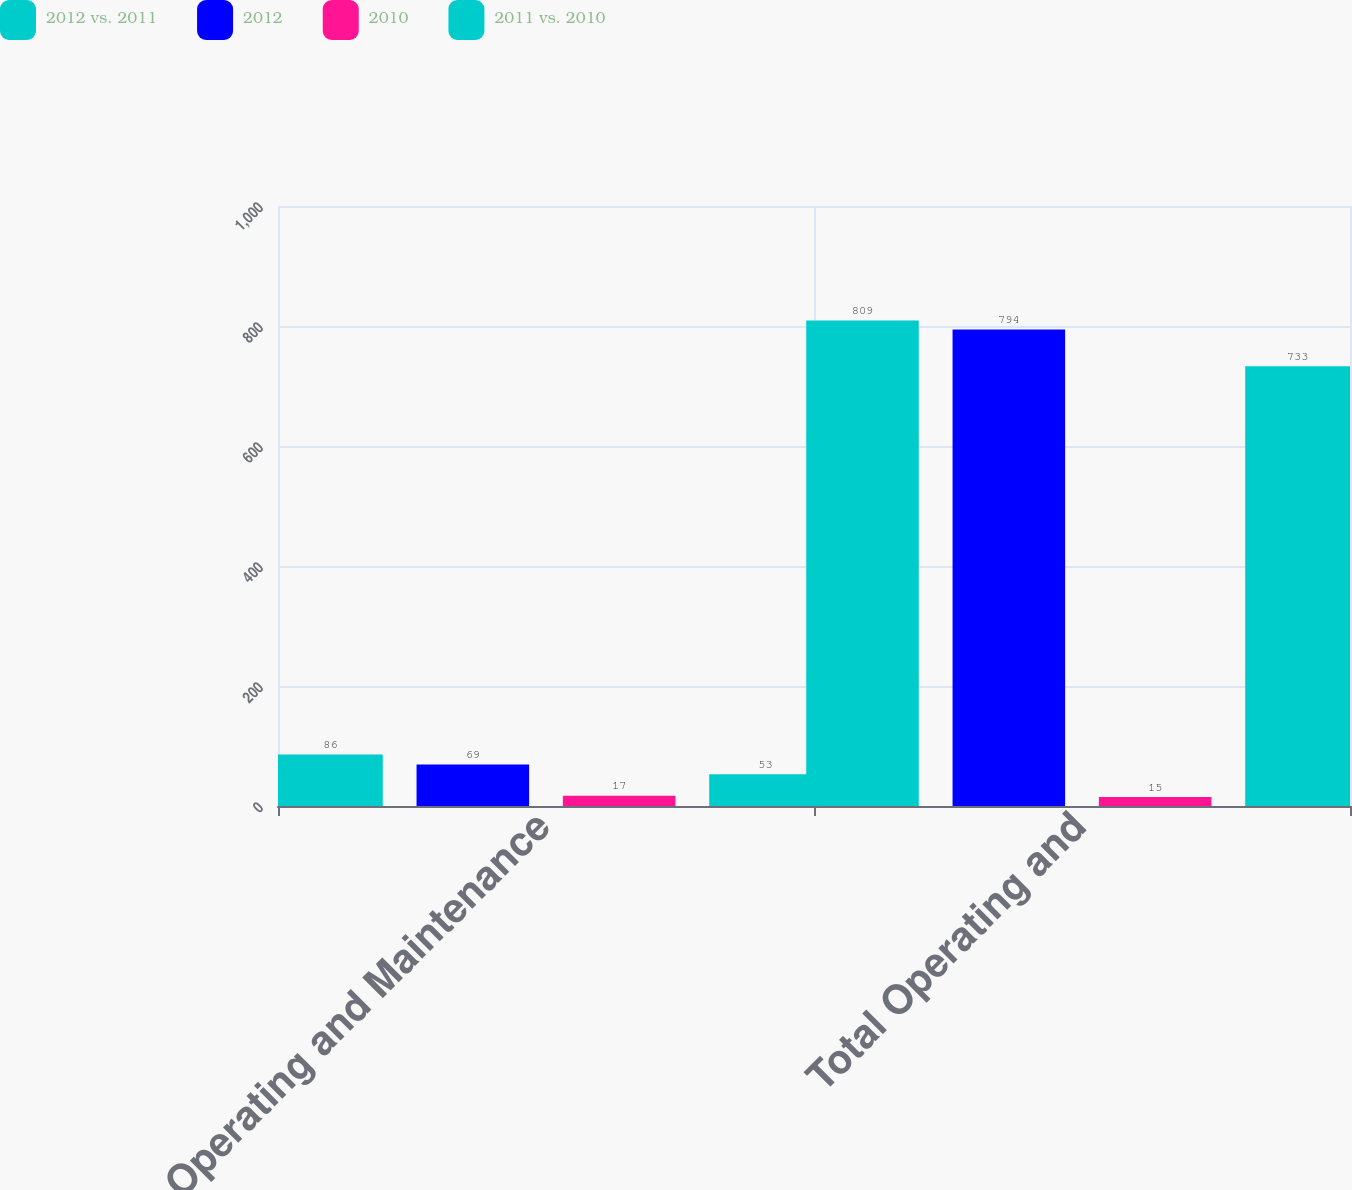Convert chart to OTSL. <chart><loc_0><loc_0><loc_500><loc_500><stacked_bar_chart><ecel><fcel>Operating and Maintenance<fcel>Total Operating and<nl><fcel>2012 vs. 2011<fcel>86<fcel>809<nl><fcel>2012<fcel>69<fcel>794<nl><fcel>2010<fcel>17<fcel>15<nl><fcel>2011 vs. 2010<fcel>53<fcel>733<nl></chart> 